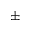Convert formula to latex. <formula><loc_0><loc_0><loc_500><loc_500>\pm</formula> 